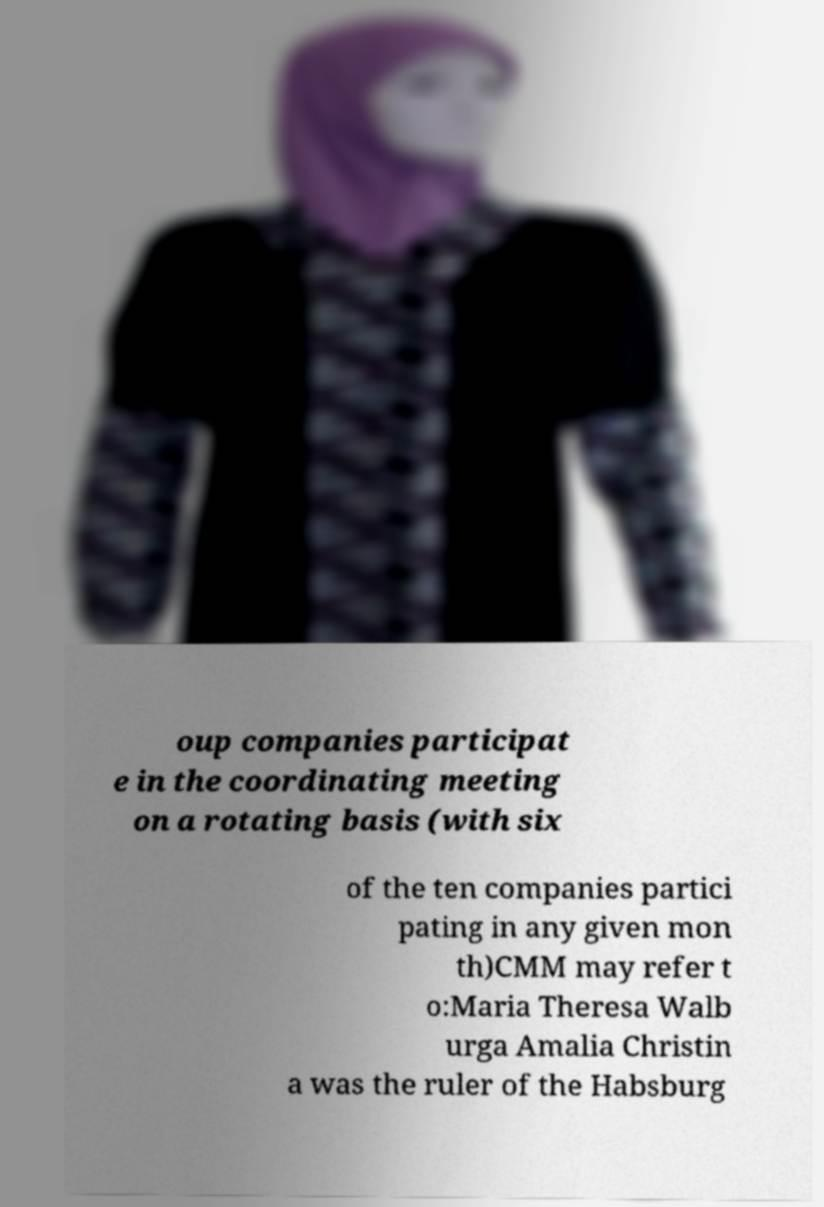Please read and relay the text visible in this image. What does it say? oup companies participat e in the coordinating meeting on a rotating basis (with six of the ten companies partici pating in any given mon th)CMM may refer t o:Maria Theresa Walb urga Amalia Christin a was the ruler of the Habsburg 